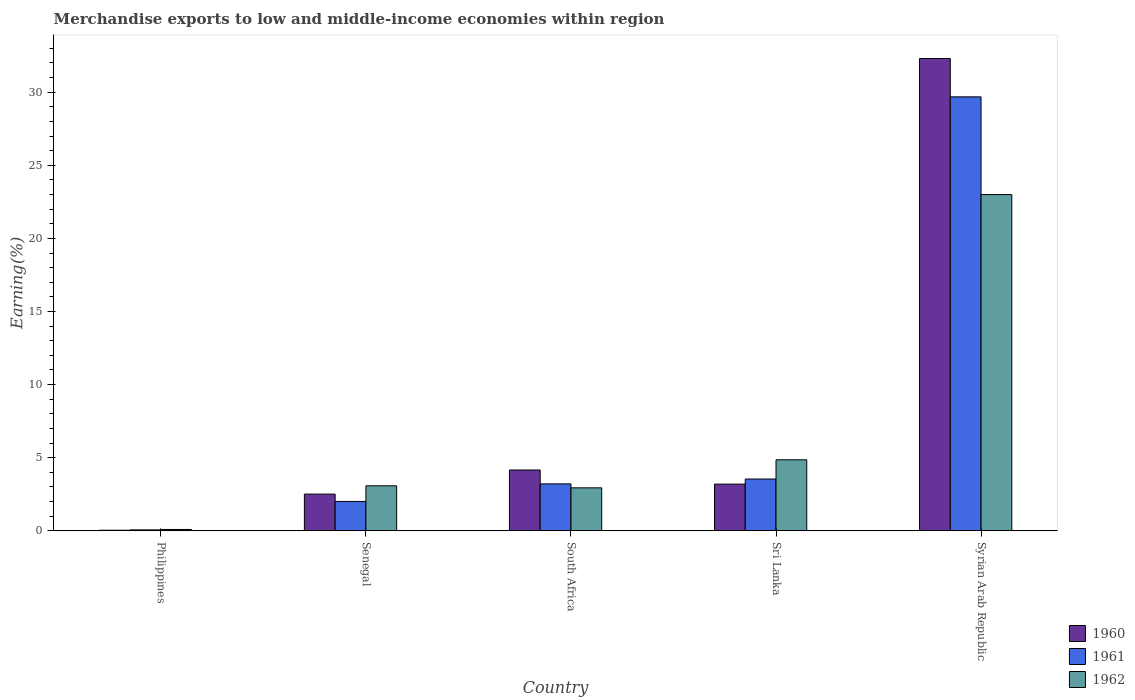How many different coloured bars are there?
Your answer should be very brief. 3. How many groups of bars are there?
Ensure brevity in your answer.  5. Are the number of bars on each tick of the X-axis equal?
Your answer should be compact. Yes. What is the label of the 2nd group of bars from the left?
Keep it short and to the point. Senegal. In how many cases, is the number of bars for a given country not equal to the number of legend labels?
Provide a succinct answer. 0. What is the percentage of amount earned from merchandise exports in 1961 in Sri Lanka?
Your answer should be compact. 3.54. Across all countries, what is the maximum percentage of amount earned from merchandise exports in 1960?
Your answer should be very brief. 32.31. Across all countries, what is the minimum percentage of amount earned from merchandise exports in 1961?
Offer a terse response. 0.06. In which country was the percentage of amount earned from merchandise exports in 1962 maximum?
Your answer should be compact. Syrian Arab Republic. What is the total percentage of amount earned from merchandise exports in 1960 in the graph?
Your answer should be compact. 42.21. What is the difference between the percentage of amount earned from merchandise exports in 1960 in Philippines and that in Syrian Arab Republic?
Offer a very short reply. -32.27. What is the difference between the percentage of amount earned from merchandise exports in 1961 in Syrian Arab Republic and the percentage of amount earned from merchandise exports in 1962 in Sri Lanka?
Make the answer very short. 24.83. What is the average percentage of amount earned from merchandise exports in 1961 per country?
Ensure brevity in your answer.  7.7. What is the difference between the percentage of amount earned from merchandise exports of/in 1960 and percentage of amount earned from merchandise exports of/in 1962 in Syrian Arab Republic?
Ensure brevity in your answer.  9.31. What is the ratio of the percentage of amount earned from merchandise exports in 1961 in Philippines to that in Senegal?
Provide a short and direct response. 0.03. Is the percentage of amount earned from merchandise exports in 1962 in Philippines less than that in South Africa?
Your response must be concise. Yes. What is the difference between the highest and the second highest percentage of amount earned from merchandise exports in 1961?
Ensure brevity in your answer.  -0.33. What is the difference between the highest and the lowest percentage of amount earned from merchandise exports in 1960?
Give a very brief answer. 32.27. What does the 2nd bar from the left in Philippines represents?
Give a very brief answer. 1961. What does the 1st bar from the right in Syrian Arab Republic represents?
Provide a short and direct response. 1962. Is it the case that in every country, the sum of the percentage of amount earned from merchandise exports in 1962 and percentage of amount earned from merchandise exports in 1960 is greater than the percentage of amount earned from merchandise exports in 1961?
Keep it short and to the point. Yes. Are all the bars in the graph horizontal?
Give a very brief answer. No. What is the difference between two consecutive major ticks on the Y-axis?
Offer a terse response. 5. Does the graph contain grids?
Ensure brevity in your answer.  No. Where does the legend appear in the graph?
Offer a terse response. Bottom right. How many legend labels are there?
Your answer should be compact. 3. How are the legend labels stacked?
Provide a succinct answer. Vertical. What is the title of the graph?
Make the answer very short. Merchandise exports to low and middle-income economies within region. Does "1991" appear as one of the legend labels in the graph?
Offer a terse response. No. What is the label or title of the Y-axis?
Offer a terse response. Earning(%). What is the Earning(%) in 1960 in Philippines?
Give a very brief answer. 0.04. What is the Earning(%) of 1961 in Philippines?
Your response must be concise. 0.06. What is the Earning(%) in 1962 in Philippines?
Your answer should be very brief. 0.09. What is the Earning(%) in 1960 in Senegal?
Offer a terse response. 2.51. What is the Earning(%) of 1961 in Senegal?
Offer a terse response. 2.01. What is the Earning(%) in 1962 in Senegal?
Offer a very short reply. 3.08. What is the Earning(%) in 1960 in South Africa?
Your answer should be compact. 4.16. What is the Earning(%) in 1961 in South Africa?
Keep it short and to the point. 3.21. What is the Earning(%) in 1962 in South Africa?
Ensure brevity in your answer.  2.94. What is the Earning(%) of 1960 in Sri Lanka?
Give a very brief answer. 3.19. What is the Earning(%) of 1961 in Sri Lanka?
Your answer should be very brief. 3.54. What is the Earning(%) in 1962 in Sri Lanka?
Your answer should be compact. 4.86. What is the Earning(%) in 1960 in Syrian Arab Republic?
Offer a terse response. 32.31. What is the Earning(%) in 1961 in Syrian Arab Republic?
Keep it short and to the point. 29.68. What is the Earning(%) in 1962 in Syrian Arab Republic?
Make the answer very short. 23. Across all countries, what is the maximum Earning(%) of 1960?
Give a very brief answer. 32.31. Across all countries, what is the maximum Earning(%) in 1961?
Provide a short and direct response. 29.68. Across all countries, what is the maximum Earning(%) of 1962?
Offer a very short reply. 23. Across all countries, what is the minimum Earning(%) in 1960?
Give a very brief answer. 0.04. Across all countries, what is the minimum Earning(%) in 1961?
Offer a very short reply. 0.06. Across all countries, what is the minimum Earning(%) in 1962?
Offer a terse response. 0.09. What is the total Earning(%) of 1960 in the graph?
Provide a short and direct response. 42.2. What is the total Earning(%) in 1961 in the graph?
Provide a succinct answer. 38.5. What is the total Earning(%) in 1962 in the graph?
Make the answer very short. 33.96. What is the difference between the Earning(%) of 1960 in Philippines and that in Senegal?
Give a very brief answer. -2.47. What is the difference between the Earning(%) in 1961 in Philippines and that in Senegal?
Offer a terse response. -1.95. What is the difference between the Earning(%) in 1962 in Philippines and that in Senegal?
Provide a short and direct response. -2.99. What is the difference between the Earning(%) in 1960 in Philippines and that in South Africa?
Provide a succinct answer. -4.12. What is the difference between the Earning(%) in 1961 in Philippines and that in South Africa?
Give a very brief answer. -3.15. What is the difference between the Earning(%) of 1962 in Philippines and that in South Africa?
Make the answer very short. -2.85. What is the difference between the Earning(%) in 1960 in Philippines and that in Sri Lanka?
Ensure brevity in your answer.  -3.16. What is the difference between the Earning(%) of 1961 in Philippines and that in Sri Lanka?
Keep it short and to the point. -3.48. What is the difference between the Earning(%) of 1962 in Philippines and that in Sri Lanka?
Ensure brevity in your answer.  -4.77. What is the difference between the Earning(%) of 1960 in Philippines and that in Syrian Arab Republic?
Your response must be concise. -32.27. What is the difference between the Earning(%) in 1961 in Philippines and that in Syrian Arab Republic?
Your answer should be compact. -29.62. What is the difference between the Earning(%) of 1962 in Philippines and that in Syrian Arab Republic?
Provide a short and direct response. -22.91. What is the difference between the Earning(%) in 1960 in Senegal and that in South Africa?
Make the answer very short. -1.65. What is the difference between the Earning(%) in 1961 in Senegal and that in South Africa?
Provide a short and direct response. -1.2. What is the difference between the Earning(%) in 1962 in Senegal and that in South Africa?
Your answer should be compact. 0.14. What is the difference between the Earning(%) in 1960 in Senegal and that in Sri Lanka?
Offer a terse response. -0.68. What is the difference between the Earning(%) in 1961 in Senegal and that in Sri Lanka?
Provide a short and direct response. -1.53. What is the difference between the Earning(%) in 1962 in Senegal and that in Sri Lanka?
Your answer should be compact. -1.78. What is the difference between the Earning(%) of 1960 in Senegal and that in Syrian Arab Republic?
Make the answer very short. -29.8. What is the difference between the Earning(%) in 1961 in Senegal and that in Syrian Arab Republic?
Your answer should be compact. -27.68. What is the difference between the Earning(%) of 1962 in Senegal and that in Syrian Arab Republic?
Offer a terse response. -19.92. What is the difference between the Earning(%) in 1960 in South Africa and that in Sri Lanka?
Provide a succinct answer. 0.96. What is the difference between the Earning(%) of 1961 in South Africa and that in Sri Lanka?
Give a very brief answer. -0.33. What is the difference between the Earning(%) in 1962 in South Africa and that in Sri Lanka?
Keep it short and to the point. -1.92. What is the difference between the Earning(%) of 1960 in South Africa and that in Syrian Arab Republic?
Offer a very short reply. -28.15. What is the difference between the Earning(%) in 1961 in South Africa and that in Syrian Arab Republic?
Keep it short and to the point. -26.47. What is the difference between the Earning(%) of 1962 in South Africa and that in Syrian Arab Republic?
Keep it short and to the point. -20.06. What is the difference between the Earning(%) in 1960 in Sri Lanka and that in Syrian Arab Republic?
Your response must be concise. -29.11. What is the difference between the Earning(%) of 1961 in Sri Lanka and that in Syrian Arab Republic?
Give a very brief answer. -26.14. What is the difference between the Earning(%) of 1962 in Sri Lanka and that in Syrian Arab Republic?
Ensure brevity in your answer.  -18.14. What is the difference between the Earning(%) of 1960 in Philippines and the Earning(%) of 1961 in Senegal?
Keep it short and to the point. -1.97. What is the difference between the Earning(%) of 1960 in Philippines and the Earning(%) of 1962 in Senegal?
Give a very brief answer. -3.04. What is the difference between the Earning(%) of 1961 in Philippines and the Earning(%) of 1962 in Senegal?
Offer a very short reply. -3.02. What is the difference between the Earning(%) in 1960 in Philippines and the Earning(%) in 1961 in South Africa?
Your answer should be compact. -3.17. What is the difference between the Earning(%) in 1960 in Philippines and the Earning(%) in 1962 in South Africa?
Give a very brief answer. -2.9. What is the difference between the Earning(%) in 1961 in Philippines and the Earning(%) in 1962 in South Africa?
Your response must be concise. -2.88. What is the difference between the Earning(%) in 1960 in Philippines and the Earning(%) in 1961 in Sri Lanka?
Provide a short and direct response. -3.5. What is the difference between the Earning(%) in 1960 in Philippines and the Earning(%) in 1962 in Sri Lanka?
Your answer should be very brief. -4.82. What is the difference between the Earning(%) in 1961 in Philippines and the Earning(%) in 1962 in Sri Lanka?
Provide a succinct answer. -4.8. What is the difference between the Earning(%) in 1960 in Philippines and the Earning(%) in 1961 in Syrian Arab Republic?
Your answer should be compact. -29.65. What is the difference between the Earning(%) in 1960 in Philippines and the Earning(%) in 1962 in Syrian Arab Republic?
Keep it short and to the point. -22.96. What is the difference between the Earning(%) in 1961 in Philippines and the Earning(%) in 1962 in Syrian Arab Republic?
Offer a terse response. -22.94. What is the difference between the Earning(%) in 1960 in Senegal and the Earning(%) in 1961 in South Africa?
Your answer should be compact. -0.7. What is the difference between the Earning(%) of 1960 in Senegal and the Earning(%) of 1962 in South Africa?
Your answer should be compact. -0.43. What is the difference between the Earning(%) of 1961 in Senegal and the Earning(%) of 1962 in South Africa?
Make the answer very short. -0.93. What is the difference between the Earning(%) of 1960 in Senegal and the Earning(%) of 1961 in Sri Lanka?
Provide a short and direct response. -1.03. What is the difference between the Earning(%) in 1960 in Senegal and the Earning(%) in 1962 in Sri Lanka?
Offer a very short reply. -2.35. What is the difference between the Earning(%) of 1961 in Senegal and the Earning(%) of 1962 in Sri Lanka?
Keep it short and to the point. -2.85. What is the difference between the Earning(%) in 1960 in Senegal and the Earning(%) in 1961 in Syrian Arab Republic?
Make the answer very short. -27.17. What is the difference between the Earning(%) in 1960 in Senegal and the Earning(%) in 1962 in Syrian Arab Republic?
Ensure brevity in your answer.  -20.49. What is the difference between the Earning(%) in 1961 in Senegal and the Earning(%) in 1962 in Syrian Arab Republic?
Your answer should be compact. -20.99. What is the difference between the Earning(%) of 1960 in South Africa and the Earning(%) of 1961 in Sri Lanka?
Your response must be concise. 0.62. What is the difference between the Earning(%) in 1960 in South Africa and the Earning(%) in 1962 in Sri Lanka?
Offer a terse response. -0.7. What is the difference between the Earning(%) in 1961 in South Africa and the Earning(%) in 1962 in Sri Lanka?
Your response must be concise. -1.65. What is the difference between the Earning(%) in 1960 in South Africa and the Earning(%) in 1961 in Syrian Arab Republic?
Your response must be concise. -25.53. What is the difference between the Earning(%) in 1960 in South Africa and the Earning(%) in 1962 in Syrian Arab Republic?
Keep it short and to the point. -18.84. What is the difference between the Earning(%) of 1961 in South Africa and the Earning(%) of 1962 in Syrian Arab Republic?
Your answer should be very brief. -19.79. What is the difference between the Earning(%) of 1960 in Sri Lanka and the Earning(%) of 1961 in Syrian Arab Republic?
Provide a short and direct response. -26.49. What is the difference between the Earning(%) in 1960 in Sri Lanka and the Earning(%) in 1962 in Syrian Arab Republic?
Give a very brief answer. -19.8. What is the difference between the Earning(%) of 1961 in Sri Lanka and the Earning(%) of 1962 in Syrian Arab Republic?
Your answer should be compact. -19.46. What is the average Earning(%) of 1960 per country?
Make the answer very short. 8.44. What is the average Earning(%) of 1961 per country?
Offer a terse response. 7.7. What is the average Earning(%) of 1962 per country?
Offer a terse response. 6.79. What is the difference between the Earning(%) of 1960 and Earning(%) of 1961 in Philippines?
Provide a short and direct response. -0.02. What is the difference between the Earning(%) of 1960 and Earning(%) of 1962 in Philippines?
Your response must be concise. -0.05. What is the difference between the Earning(%) of 1961 and Earning(%) of 1962 in Philippines?
Offer a terse response. -0.03. What is the difference between the Earning(%) of 1960 and Earning(%) of 1961 in Senegal?
Your answer should be very brief. 0.5. What is the difference between the Earning(%) of 1960 and Earning(%) of 1962 in Senegal?
Your answer should be very brief. -0.57. What is the difference between the Earning(%) in 1961 and Earning(%) in 1962 in Senegal?
Keep it short and to the point. -1.07. What is the difference between the Earning(%) in 1960 and Earning(%) in 1961 in South Africa?
Give a very brief answer. 0.95. What is the difference between the Earning(%) of 1960 and Earning(%) of 1962 in South Africa?
Your answer should be very brief. 1.22. What is the difference between the Earning(%) in 1961 and Earning(%) in 1962 in South Africa?
Ensure brevity in your answer.  0.27. What is the difference between the Earning(%) of 1960 and Earning(%) of 1961 in Sri Lanka?
Ensure brevity in your answer.  -0.35. What is the difference between the Earning(%) of 1960 and Earning(%) of 1962 in Sri Lanka?
Your answer should be very brief. -1.66. What is the difference between the Earning(%) of 1961 and Earning(%) of 1962 in Sri Lanka?
Offer a very short reply. -1.32. What is the difference between the Earning(%) of 1960 and Earning(%) of 1961 in Syrian Arab Republic?
Provide a short and direct response. 2.62. What is the difference between the Earning(%) of 1960 and Earning(%) of 1962 in Syrian Arab Republic?
Provide a succinct answer. 9.31. What is the difference between the Earning(%) in 1961 and Earning(%) in 1962 in Syrian Arab Republic?
Ensure brevity in your answer.  6.68. What is the ratio of the Earning(%) in 1960 in Philippines to that in Senegal?
Your answer should be compact. 0.01. What is the ratio of the Earning(%) of 1961 in Philippines to that in Senegal?
Keep it short and to the point. 0.03. What is the ratio of the Earning(%) of 1962 in Philippines to that in Senegal?
Provide a short and direct response. 0.03. What is the ratio of the Earning(%) of 1960 in Philippines to that in South Africa?
Make the answer very short. 0.01. What is the ratio of the Earning(%) in 1961 in Philippines to that in South Africa?
Your response must be concise. 0.02. What is the ratio of the Earning(%) of 1962 in Philippines to that in South Africa?
Provide a short and direct response. 0.03. What is the ratio of the Earning(%) of 1960 in Philippines to that in Sri Lanka?
Your answer should be very brief. 0.01. What is the ratio of the Earning(%) of 1961 in Philippines to that in Sri Lanka?
Provide a succinct answer. 0.02. What is the ratio of the Earning(%) in 1962 in Philippines to that in Sri Lanka?
Offer a terse response. 0.02. What is the ratio of the Earning(%) of 1960 in Philippines to that in Syrian Arab Republic?
Give a very brief answer. 0. What is the ratio of the Earning(%) in 1961 in Philippines to that in Syrian Arab Republic?
Make the answer very short. 0. What is the ratio of the Earning(%) in 1962 in Philippines to that in Syrian Arab Republic?
Your answer should be very brief. 0. What is the ratio of the Earning(%) of 1960 in Senegal to that in South Africa?
Your answer should be compact. 0.6. What is the ratio of the Earning(%) of 1961 in Senegal to that in South Africa?
Make the answer very short. 0.63. What is the ratio of the Earning(%) in 1962 in Senegal to that in South Africa?
Give a very brief answer. 1.05. What is the ratio of the Earning(%) of 1960 in Senegal to that in Sri Lanka?
Your answer should be compact. 0.79. What is the ratio of the Earning(%) in 1961 in Senegal to that in Sri Lanka?
Provide a short and direct response. 0.57. What is the ratio of the Earning(%) of 1962 in Senegal to that in Sri Lanka?
Make the answer very short. 0.63. What is the ratio of the Earning(%) of 1960 in Senegal to that in Syrian Arab Republic?
Provide a succinct answer. 0.08. What is the ratio of the Earning(%) of 1961 in Senegal to that in Syrian Arab Republic?
Keep it short and to the point. 0.07. What is the ratio of the Earning(%) of 1962 in Senegal to that in Syrian Arab Republic?
Offer a very short reply. 0.13. What is the ratio of the Earning(%) of 1960 in South Africa to that in Sri Lanka?
Provide a short and direct response. 1.3. What is the ratio of the Earning(%) in 1961 in South Africa to that in Sri Lanka?
Provide a succinct answer. 0.91. What is the ratio of the Earning(%) of 1962 in South Africa to that in Sri Lanka?
Ensure brevity in your answer.  0.6. What is the ratio of the Earning(%) in 1960 in South Africa to that in Syrian Arab Republic?
Your answer should be compact. 0.13. What is the ratio of the Earning(%) of 1961 in South Africa to that in Syrian Arab Republic?
Make the answer very short. 0.11. What is the ratio of the Earning(%) of 1962 in South Africa to that in Syrian Arab Republic?
Ensure brevity in your answer.  0.13. What is the ratio of the Earning(%) of 1960 in Sri Lanka to that in Syrian Arab Republic?
Your answer should be very brief. 0.1. What is the ratio of the Earning(%) of 1961 in Sri Lanka to that in Syrian Arab Republic?
Ensure brevity in your answer.  0.12. What is the ratio of the Earning(%) of 1962 in Sri Lanka to that in Syrian Arab Republic?
Keep it short and to the point. 0.21. What is the difference between the highest and the second highest Earning(%) in 1960?
Your response must be concise. 28.15. What is the difference between the highest and the second highest Earning(%) in 1961?
Make the answer very short. 26.14. What is the difference between the highest and the second highest Earning(%) of 1962?
Make the answer very short. 18.14. What is the difference between the highest and the lowest Earning(%) in 1960?
Give a very brief answer. 32.27. What is the difference between the highest and the lowest Earning(%) in 1961?
Give a very brief answer. 29.62. What is the difference between the highest and the lowest Earning(%) in 1962?
Offer a very short reply. 22.91. 